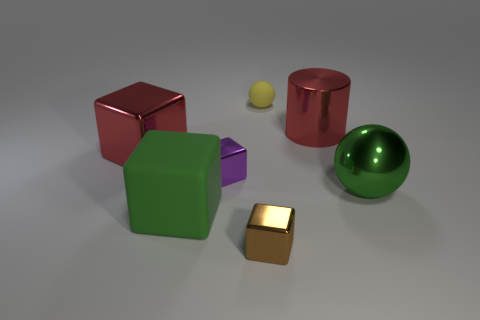Do the large red cylinder and the sphere in front of the red block have the same material?
Keep it short and to the point. Yes. How many small red metallic balls are there?
Keep it short and to the point. 0. There is a red metal thing left of the yellow object; what size is it?
Your answer should be very brief. Large. What number of blue shiny cubes have the same size as the matte sphere?
Your answer should be very brief. 0. There is a block that is both in front of the large sphere and left of the brown block; what is its material?
Make the answer very short. Rubber. There is a yellow object that is the same size as the purple shiny cube; what is it made of?
Your response must be concise. Rubber. What size is the rubber object behind the ball that is in front of the big red object on the right side of the rubber ball?
Your answer should be very brief. Small. There is a green object that is made of the same material as the purple object; what is its size?
Provide a succinct answer. Large. There is a red metal cylinder; does it have the same size as the metallic cube to the right of the small purple metallic thing?
Provide a succinct answer. No. There is a red metallic object that is to the right of the small matte sphere; what is its shape?
Your answer should be compact. Cylinder. 